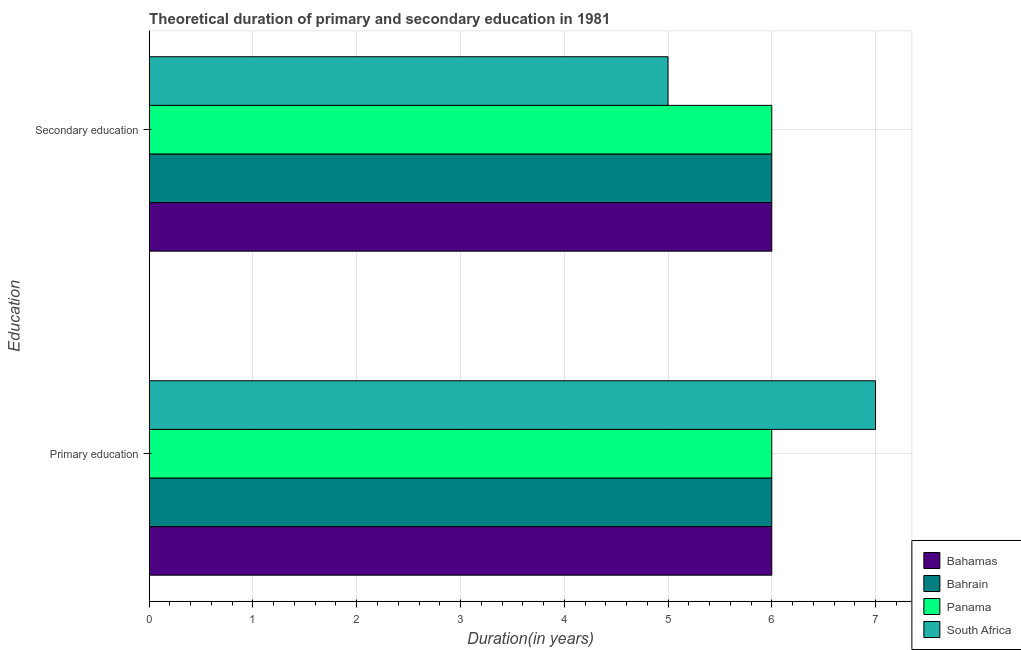How many different coloured bars are there?
Ensure brevity in your answer.  4. Are the number of bars per tick equal to the number of legend labels?
Provide a succinct answer. Yes. What is the duration of primary education in Bahrain?
Provide a short and direct response. 6. Across all countries, what is the maximum duration of primary education?
Your answer should be compact. 7. Across all countries, what is the minimum duration of secondary education?
Keep it short and to the point. 5. In which country was the duration of secondary education maximum?
Your answer should be very brief. Bahamas. In which country was the duration of primary education minimum?
Keep it short and to the point. Bahamas. What is the total duration of primary education in the graph?
Make the answer very short. 25. What is the difference between the duration of primary education in Bahamas and that in South Africa?
Your answer should be compact. -1. What is the average duration of primary education per country?
Provide a short and direct response. 6.25. In how many countries, is the duration of secondary education greater than 4.8 years?
Provide a succinct answer. 4. Is the duration of primary education in Bahrain less than that in Panama?
Your answer should be very brief. No. What does the 2nd bar from the top in Secondary education represents?
Keep it short and to the point. Panama. What does the 4th bar from the bottom in Secondary education represents?
Your answer should be compact. South Africa. How many bars are there?
Offer a terse response. 8. Are all the bars in the graph horizontal?
Give a very brief answer. Yes. How many countries are there in the graph?
Offer a very short reply. 4. Are the values on the major ticks of X-axis written in scientific E-notation?
Your answer should be compact. No. Does the graph contain any zero values?
Your response must be concise. No. Does the graph contain grids?
Make the answer very short. Yes. Where does the legend appear in the graph?
Offer a terse response. Bottom right. How are the legend labels stacked?
Your response must be concise. Vertical. What is the title of the graph?
Provide a succinct answer. Theoretical duration of primary and secondary education in 1981. Does "Sri Lanka" appear as one of the legend labels in the graph?
Ensure brevity in your answer.  No. What is the label or title of the X-axis?
Your response must be concise. Duration(in years). What is the label or title of the Y-axis?
Your answer should be compact. Education. What is the Duration(in years) of Bahamas in Primary education?
Ensure brevity in your answer.  6. What is the Duration(in years) in Bahrain in Primary education?
Your answer should be compact. 6. What is the Duration(in years) of Panama in Primary education?
Your answer should be very brief. 6. What is the Duration(in years) in South Africa in Primary education?
Your answer should be compact. 7. What is the Duration(in years) of Bahamas in Secondary education?
Keep it short and to the point. 6. What is the Duration(in years) of South Africa in Secondary education?
Your answer should be very brief. 5. Across all Education, what is the minimum Duration(in years) in Bahrain?
Make the answer very short. 6. What is the total Duration(in years) in Panama in the graph?
Your response must be concise. 12. What is the difference between the Duration(in years) of Bahrain in Primary education and that in Secondary education?
Your response must be concise. 0. What is the difference between the Duration(in years) in Panama in Primary education and that in Secondary education?
Keep it short and to the point. 0. What is the difference between the Duration(in years) of South Africa in Primary education and that in Secondary education?
Your response must be concise. 2. What is the difference between the Duration(in years) of Bahamas in Primary education and the Duration(in years) of South Africa in Secondary education?
Your response must be concise. 1. What is the difference between the Duration(in years) in Bahrain in Primary education and the Duration(in years) in Panama in Secondary education?
Keep it short and to the point. 0. What is the difference between the Duration(in years) in Panama in Primary education and the Duration(in years) in South Africa in Secondary education?
Give a very brief answer. 1. What is the average Duration(in years) of Bahamas per Education?
Offer a very short reply. 6. What is the average Duration(in years) of Bahrain per Education?
Give a very brief answer. 6. What is the average Duration(in years) of Panama per Education?
Ensure brevity in your answer.  6. What is the average Duration(in years) of South Africa per Education?
Ensure brevity in your answer.  6. What is the difference between the Duration(in years) in Bahamas and Duration(in years) in Panama in Primary education?
Ensure brevity in your answer.  0. What is the difference between the Duration(in years) in Bahrain and Duration(in years) in Panama in Primary education?
Your answer should be very brief. 0. What is the difference between the Duration(in years) of Bahrain and Duration(in years) of South Africa in Primary education?
Offer a terse response. -1. What is the difference between the Duration(in years) in Bahamas and Duration(in years) in Bahrain in Secondary education?
Keep it short and to the point. 0. What is the difference between the Duration(in years) of Bahrain and Duration(in years) of Panama in Secondary education?
Make the answer very short. 0. What is the difference between the Duration(in years) of Panama and Duration(in years) of South Africa in Secondary education?
Your answer should be very brief. 1. What is the ratio of the Duration(in years) in Panama in Primary education to that in Secondary education?
Your answer should be compact. 1. What is the ratio of the Duration(in years) in South Africa in Primary education to that in Secondary education?
Your answer should be compact. 1.4. What is the difference between the highest and the second highest Duration(in years) of Bahrain?
Provide a succinct answer. 0. What is the difference between the highest and the lowest Duration(in years) in Panama?
Provide a succinct answer. 0. What is the difference between the highest and the lowest Duration(in years) in South Africa?
Your answer should be very brief. 2. 